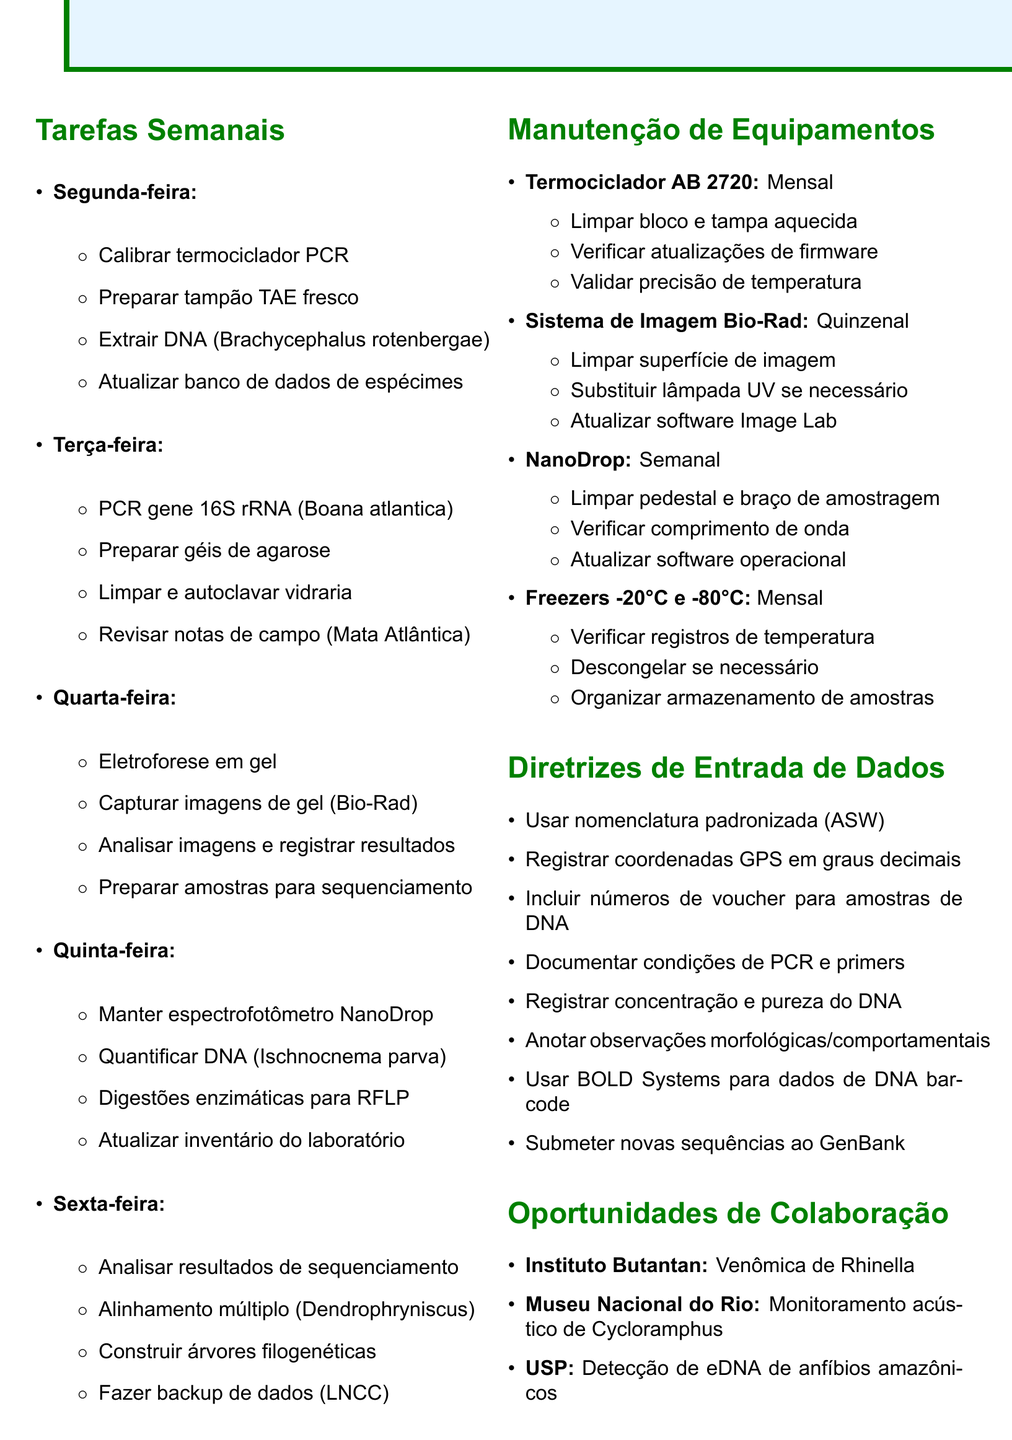What tasks are scheduled for Monday? The tasks scheduled for Monday include calibrating the PCR thermal cycler, preparing fresh TAE buffer, extracting DNA from Brachycephalus rotenbergae, and updating the specimen database.
Answer: Calibrar termociclador PCR, preparar tampão TAE fresco, extrair DNA (Brachycephalus rotenbergae), atualizar banco de dados de espécimes How often is the NanoDrop spectrophotometer maintained? The document states the maintenance frequency for the NanoDrop spectrophotometer is weekly.
Answer: Semanal What type of DNA samples are mentioned for data entry? The document specifies that voucher specimen numbers for all DNA samples should be included.
Answer: DNA samples Which software is used for DNA sequencing analysis? MEGA X software is mentioned in the document for analyzing DNA sequencing results.
Answer: MEGA X What is the purpose of the field notes review on Tuesday? The tasks include reviewing and organizing field notes from a recent expedition, which helps in documenting findings.
Answer: Documenting findings Which institution is involved in the project on Acoustic monitoring? The National Museum of Rio de Janeiro is mentioned for the project on acoustic monitoring of Cycloramphus species.
Answer: National Museum of Rio de Janeiro What equipment requires a clean pedestal weekly? The NanoDrop spectrophotometer requires a clean pedestal as part of its weekly maintenance tasks.
Answer: NanoDrop spectrophotometer How many days are allocated for analyzing gel images? The document allocates one day, Wednesday, for performing gel electrophoresis and analyzing gel images.
Answer: One day 